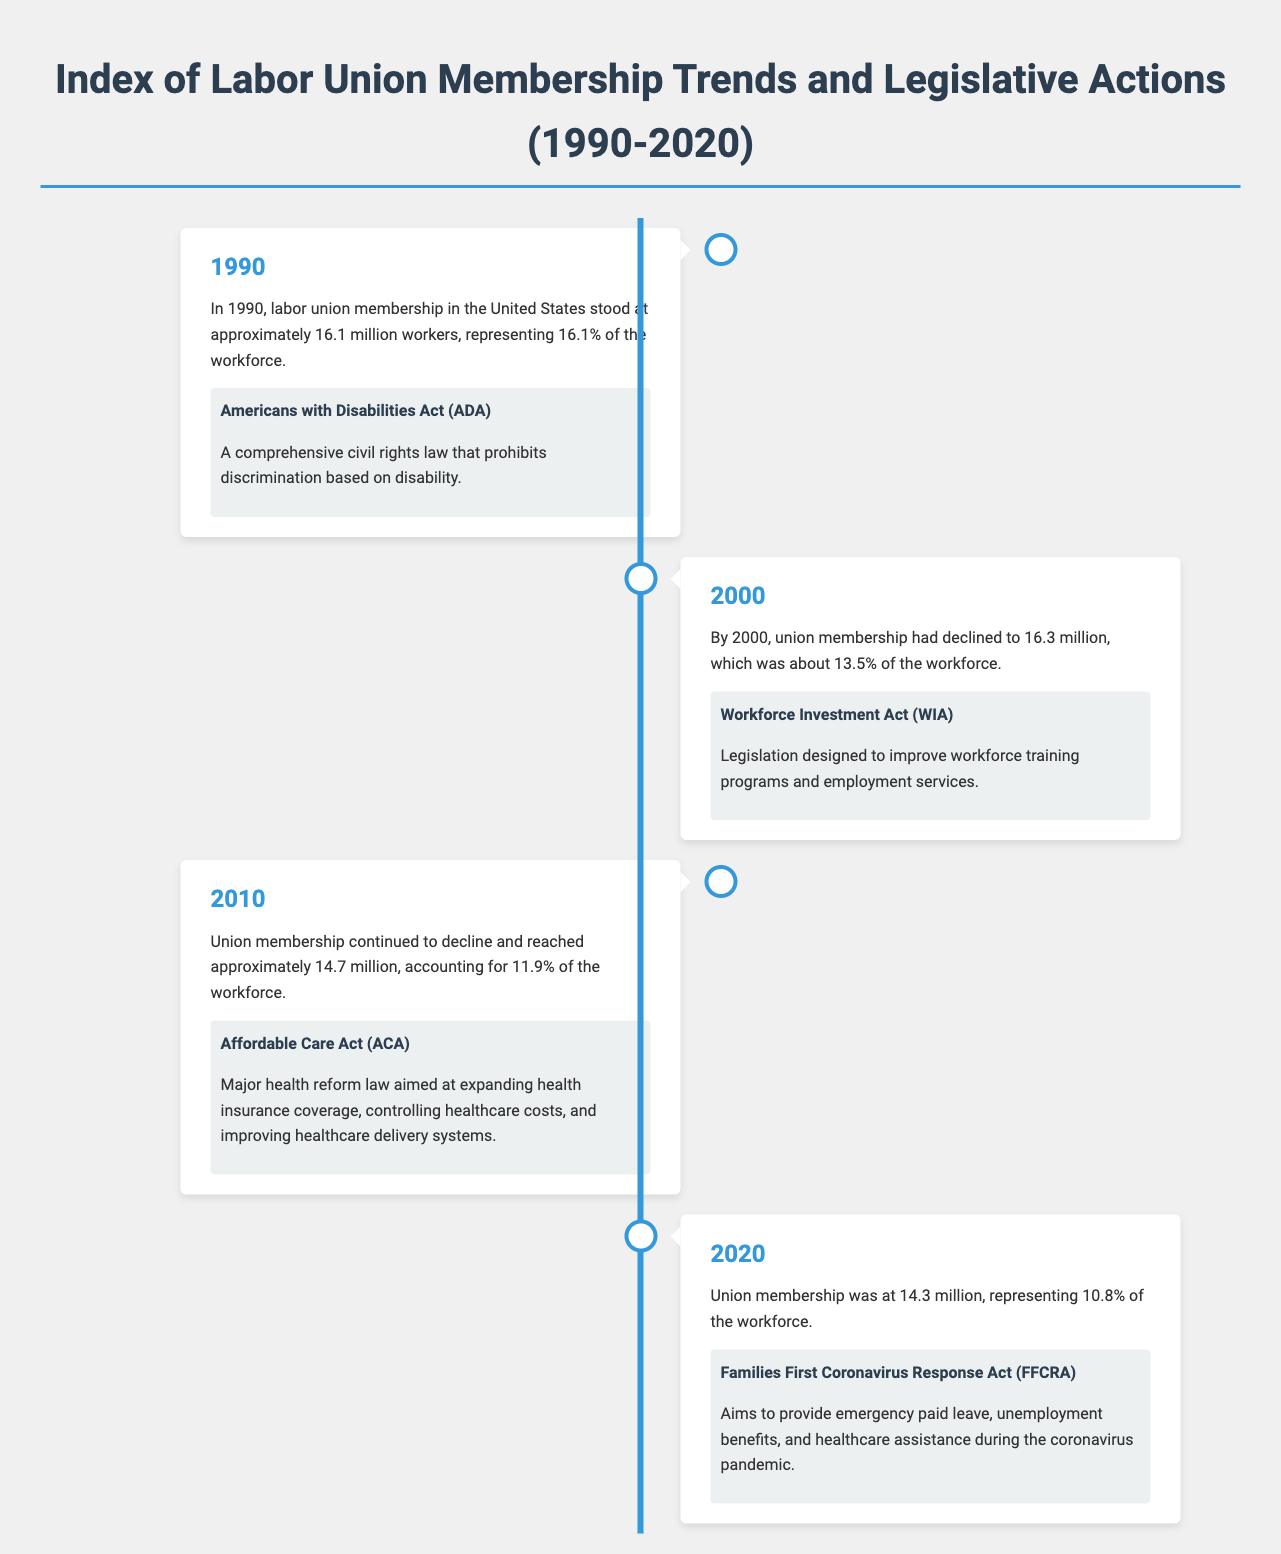What was the union membership in 1990? The document states that in 1990, labor union membership in the United States stood at approximately 16.1 million workers.
Answer: 16.1 million What percentage of the workforce did unions represent in 2000? The document indicates that by 2000, union membership represented about 13.5% of the workforce.
Answer: 13.5% Which act was passed in 2010? The document highlights that the Affordable Care Act (ACA) was a major health reform law passed in 2010.
Answer: Affordable Care Act (ACA) What was the union membership figure in 2020? According to the document, union membership was at 14.3 million in 2020.
Answer: 14.3 million Which legislation aimed to provide emergency assistance during the pandemic? The document mentions the Families First Coronavirus Response Act (FFCRA) as the legislation aimed for emergency assistance during the pandemic.
Answer: Families First Coronavirus Response Act (FFCRA) How did union membership change from 1990 to 2020? The document illustrates a decline in union membership from approximately 16.1 million in 1990 to 14.3 million in 2020.
Answer: Decline What was the approximate union membership in 2010? The document states that in 2010, union membership reached approximately 14.7 million.
Answer: 14.7 million What does the timeline in the document display? The timeline illustrates year-by-year labor union membership trends along with key legislative actions.
Answer: Year-by-year trends What type of document is this? This document is a comprehensive analysis focusing on labor union membership trends and legislative actions.
Answer: Index 